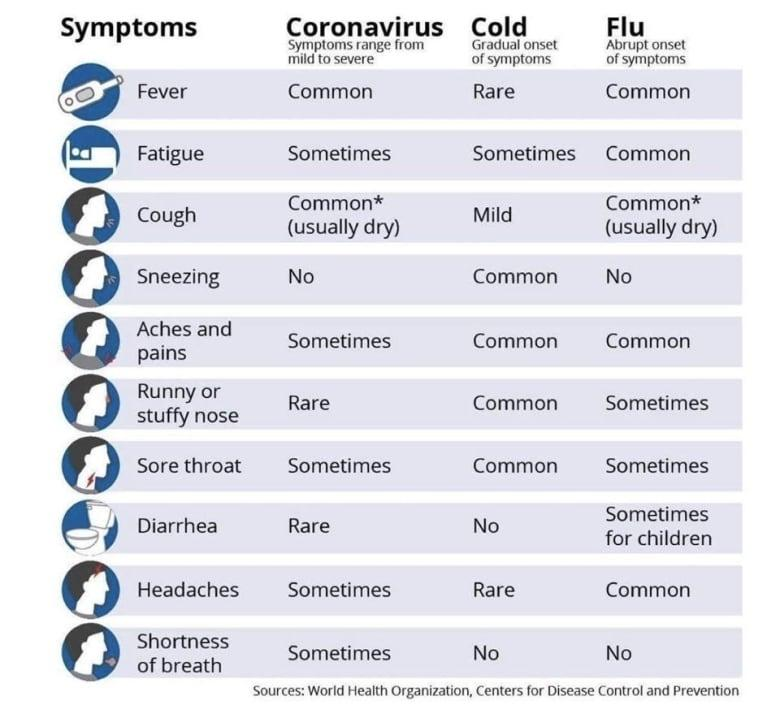Draw attention to some important aspects in this diagram. It is common for both the common cold and COVID-19 to cause fatigue in some individuals. Both Coronavirus and Flu are characterized by common symptoms such as fever and a cough. Coronavirus and Flu do not share the symptom of sneezing. The symptoms of a cold are fever and headaches, which are rare. Coronavirus is characterized by a range of symptoms, including runny or stuffy nose, and diarrhea, which are less common in other viral infections. 